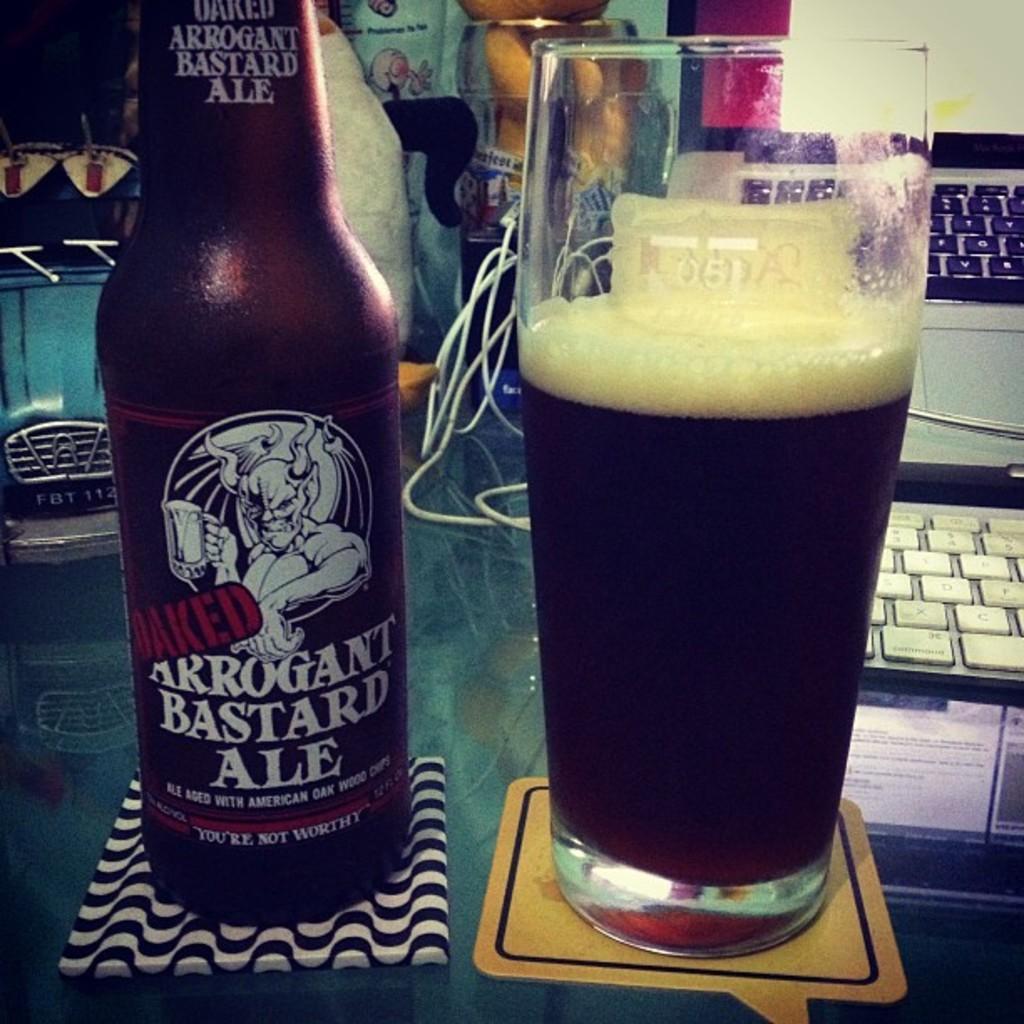Please provide a concise description of this image. In the foreground of the picture we can see bottle, glass, drink on a table. On the right we can see keyboard and laptop. On the left there is a toy. In the center of the background there are some objects, cable and wall. 